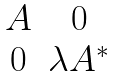<formula> <loc_0><loc_0><loc_500><loc_500>\begin{matrix} A & 0 \\ 0 & \lambda A ^ { * } \end{matrix}</formula> 